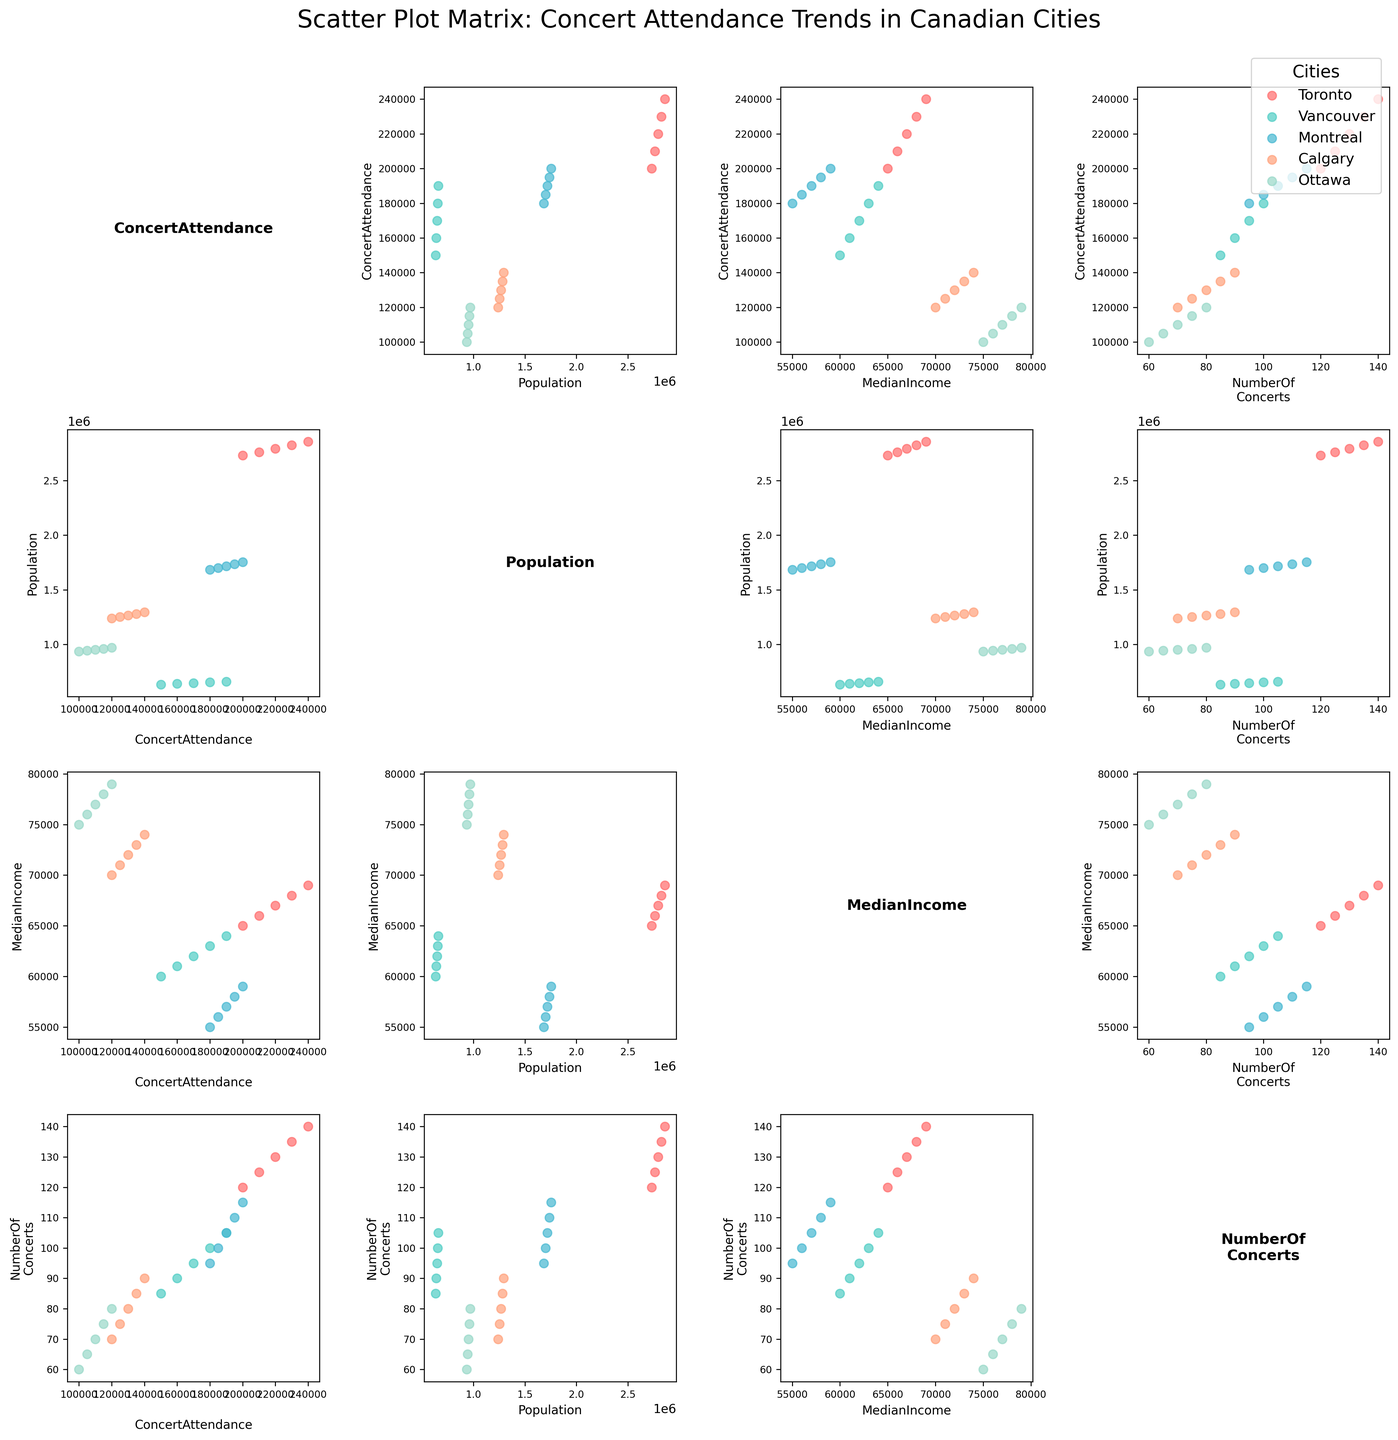How many cities are represented in the plot? To determine the number of cities, we look at the color legend in the figure. Each city is represented by a different color.
Answer: 5 What is the title of the figure? The title of the figure is usually located at the top center of the plot area.
Answer: Scatter Plot Matrix: Concert Attendance Trends in Canadian Cities Which city has the highest concert attendance in 2019? Looking at the scatter points for each city, find the ones for 2019 and compare their 'ConcertAttendance' values. Toronto has the highest attendance in this year.
Answer: Toronto Is there any trend between median income and concert attendance? Examine the scatter plots where 'MedianIncome' is plotted against 'ConcertAttendance'. There appears to be a positive correlation, meaning as median income increases, concert attendance tends to increase as well.
Answer: Positive correlation Which variable shows the strongest correlation with 'NumberOfConcerts'? Compare all the scatter plots in which 'NumberOfConcerts' is on one axis. The strongest correlation appears in the plot with 'ConcertAttendance', as a clear linear trend is visible.
Answer: ConcertAttendance How do Ottawa and Montreal compare in terms of concert attendance growth from 2015 to 2019? Look at the markers for Ottawa and Montreal across the years in the 'ConcertAttendance' rows and columns. Ottawa's attendance increased from 100,000 to 120,000, and Montreal's increased from 180,000 to 200,000.
Answer: Both cities show growth, with Montreal having a higher overall attendance What is the axis label for the fourth column in the second row? Move to the second row and look at the fourth column. The axis label corresponds to 'NumberOfConcerts'.
Answer: NumberOfConcerts If you want to identify the city with the lowest population in 2016, where would you look? Find the scatter plot where 'Population' is plotted against 'Year'. Locate the points for 2016 and identify the one with the lowest 'Population' value.
Answer: Vancouver Compare the median income of the cities. Which city has the most considerable increase in median income over the years? Check the points labeled with 'MedianIncome' and track the changes over the years for each city. Calgary shows the most noticeable increase.
Answer: Calgary 